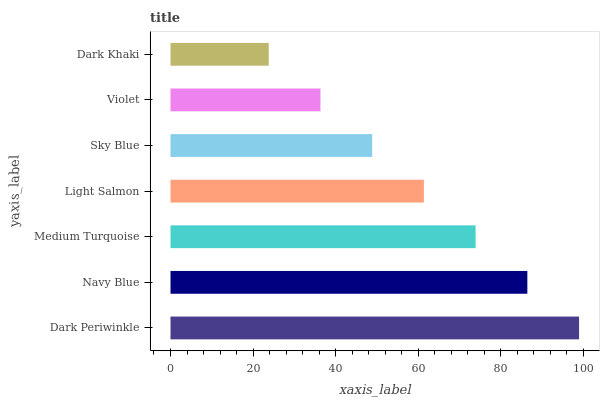Is Dark Khaki the minimum?
Answer yes or no. Yes. Is Dark Periwinkle the maximum?
Answer yes or no. Yes. Is Navy Blue the minimum?
Answer yes or no. No. Is Navy Blue the maximum?
Answer yes or no. No. Is Dark Periwinkle greater than Navy Blue?
Answer yes or no. Yes. Is Navy Blue less than Dark Periwinkle?
Answer yes or no. Yes. Is Navy Blue greater than Dark Periwinkle?
Answer yes or no. No. Is Dark Periwinkle less than Navy Blue?
Answer yes or no. No. Is Light Salmon the high median?
Answer yes or no. Yes. Is Light Salmon the low median?
Answer yes or no. Yes. Is Dark Periwinkle the high median?
Answer yes or no. No. Is Sky Blue the low median?
Answer yes or no. No. 